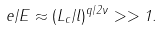Convert formula to latex. <formula><loc_0><loc_0><loc_500><loc_500>e / E \approx ( L _ { c } / l ) ^ { q / 2 \nu } > > 1 .</formula> 